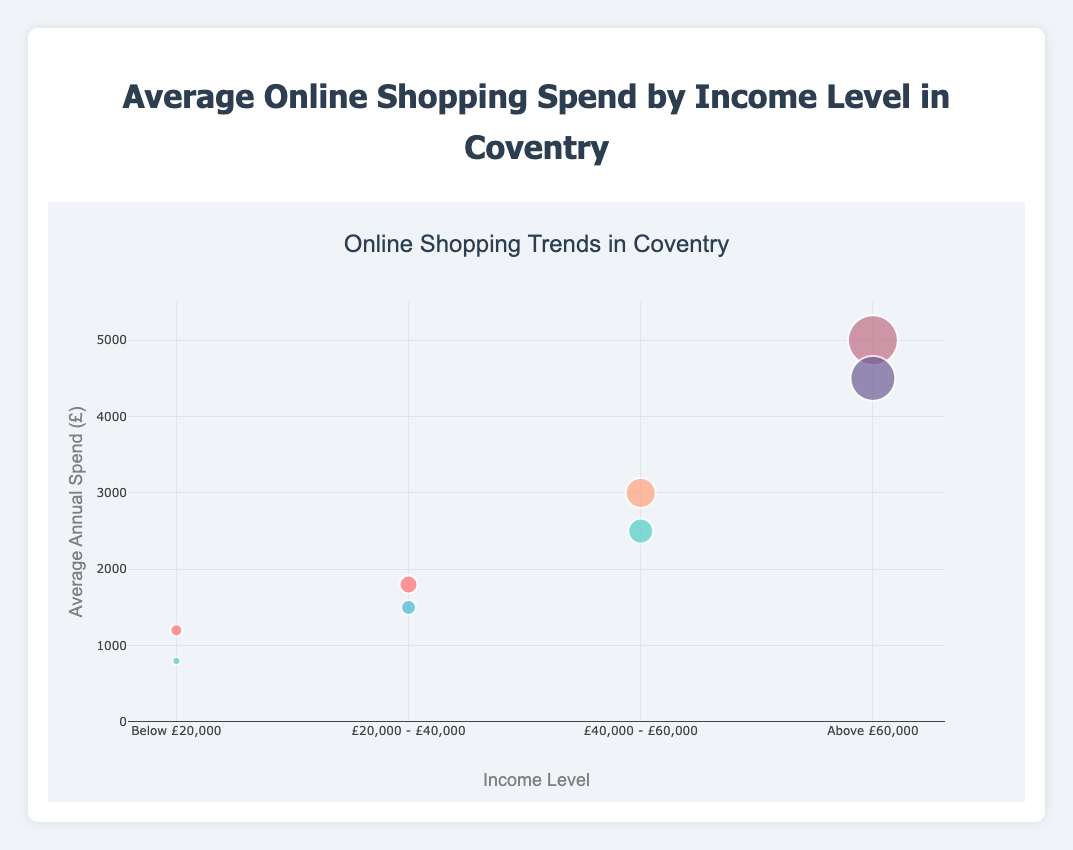What is the title of the chart? The title can be found at the top of the figure, indicating the primary subject of the chart.
Answer: Average Online Shopping Spend by Income Level in Coventry Which income level has the highest average annual spend? Look for the highest bubble on the y-axis and match its x-axis value representing the income level.
Answer: Above £60,000 What is the average annual spend for Electronics for the Below £20,000 income level? Find the bubble representing Electronics within the "Below £20,000" income level on the x-axis and check its y-axis value.
Answer: £800 How much more is the average annual spend on Home Essentials for the £40,000 - £60,000 income level compared to Groceries for the £20,000 - £40,000 income level? Check the y-axis values for "Home Essentials" in £40,000 - £60,000 and "Groceries" in £20,000 - £40,000 income levels, then subtract the smaller value from the larger value. £3000 - £1800 = £1200
Answer: £1200 Which categories have spending data for the income level £20,000 - £40,000? Check the bubbles that align with the "£20,000 - £40,000" income level on the x-axis and note down their categories.
Answer: Groceries, Clothing Between which two categories is the average annual spend highest for the £40,000 - £60,000 income level? Compare the y-axis values of the two categories that fall under the "£40,000 - £60,000" income level on the x-axis.
Answer: Home Essentials, Electronics What entity corresponds with the highest average spend in Groceries? Identify the bubble with the category "Groceries" and the largest y-axis value, then check its label.
Answer: Sainsbury's What is the color used for bubbles representing the Luxury Items category? Find the bubbles labeled "Luxury Items" and identify their color.
Answer: #C06C84 (A dark pink shade) How does the average spend on Travel for the Above £60,000 income level compare to the Electronics category for the £40,000 - £60,000 income level? Look at the y-values of Travel for the Above £60,000 income level and Electronics for the £40,000 - £60,000 income level and determine which is higher or by how much.
Answer: Travel is £2000 higher (4500-2500) How many categories have an average annual spend above £3000? Count the number of bubbles whose y-axis values are greater than £3000.
Answer: 3 